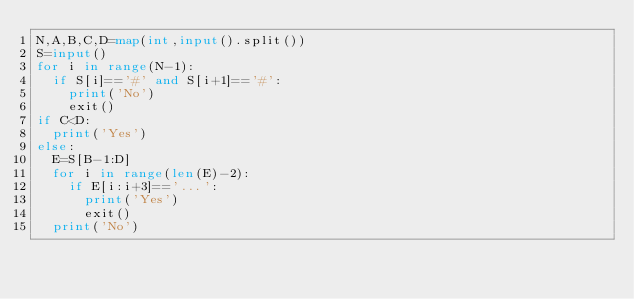<code> <loc_0><loc_0><loc_500><loc_500><_Python_>N,A,B,C,D=map(int,input().split())
S=input()
for i in range(N-1):
  if S[i]=='#' and S[i+1]=='#':
    print('No')
    exit()
if C<D:
  print('Yes')
else:
  E=S[B-1:D]
  for i in range(len(E)-2):
    if E[i:i+3]=='...':
      print('Yes')
      exit()
  print('No')</code> 